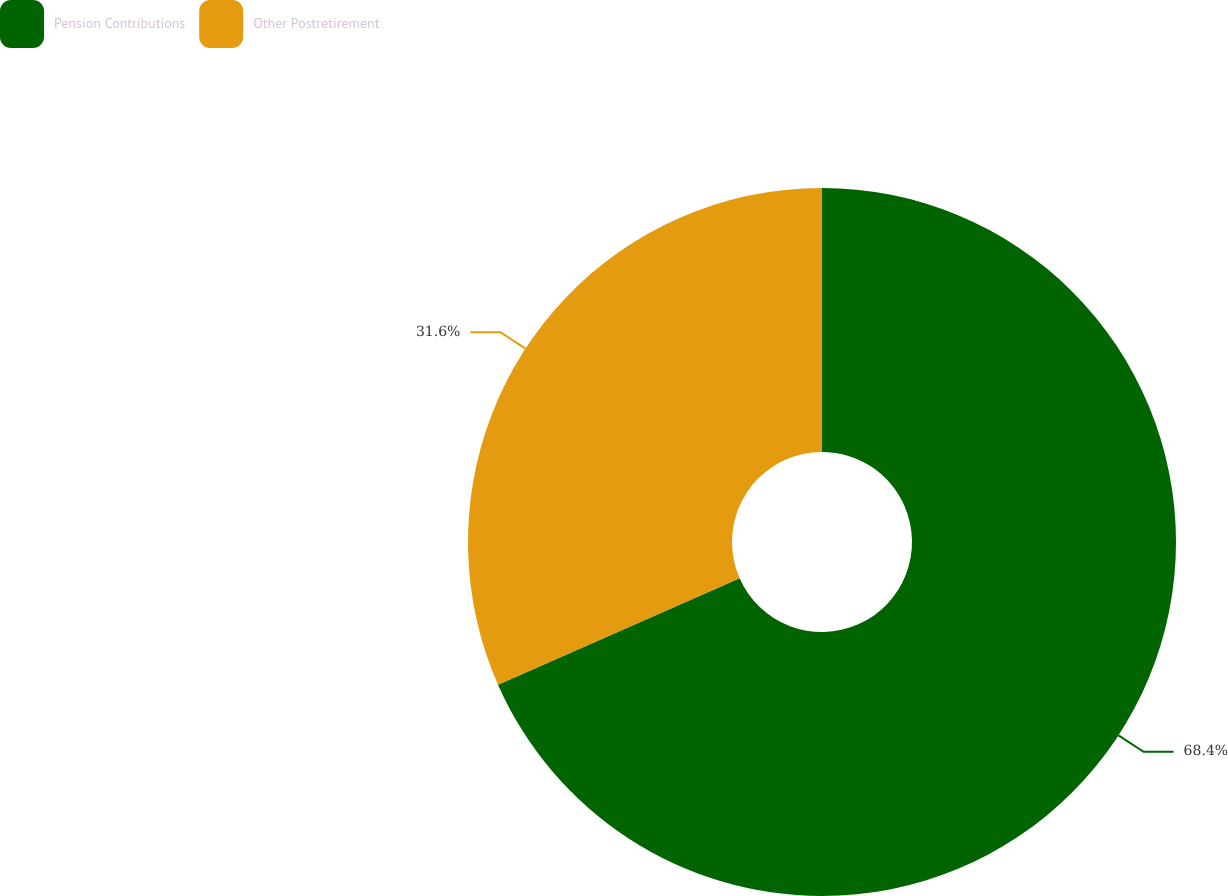<chart> <loc_0><loc_0><loc_500><loc_500><pie_chart><fcel>Pension Contributions<fcel>Other Postretirement<nl><fcel>68.4%<fcel>31.6%<nl></chart> 